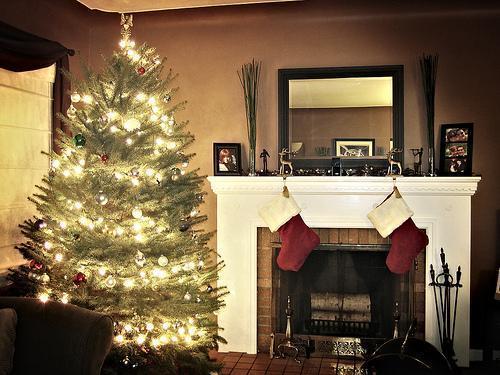How many trees are in the image?
Give a very brief answer. 1. How many stockings are on the chimney?
Give a very brief answer. 2. 